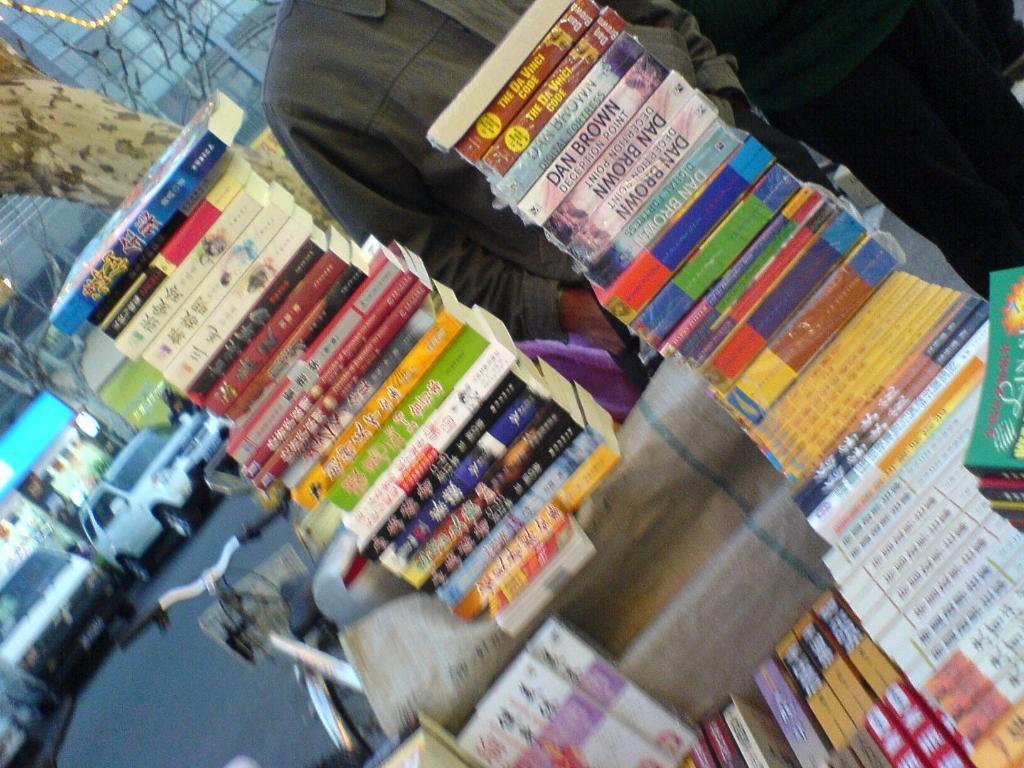<image>
Share a concise interpretation of the image provided. Rows of books some of which are written by Dan Brown. 